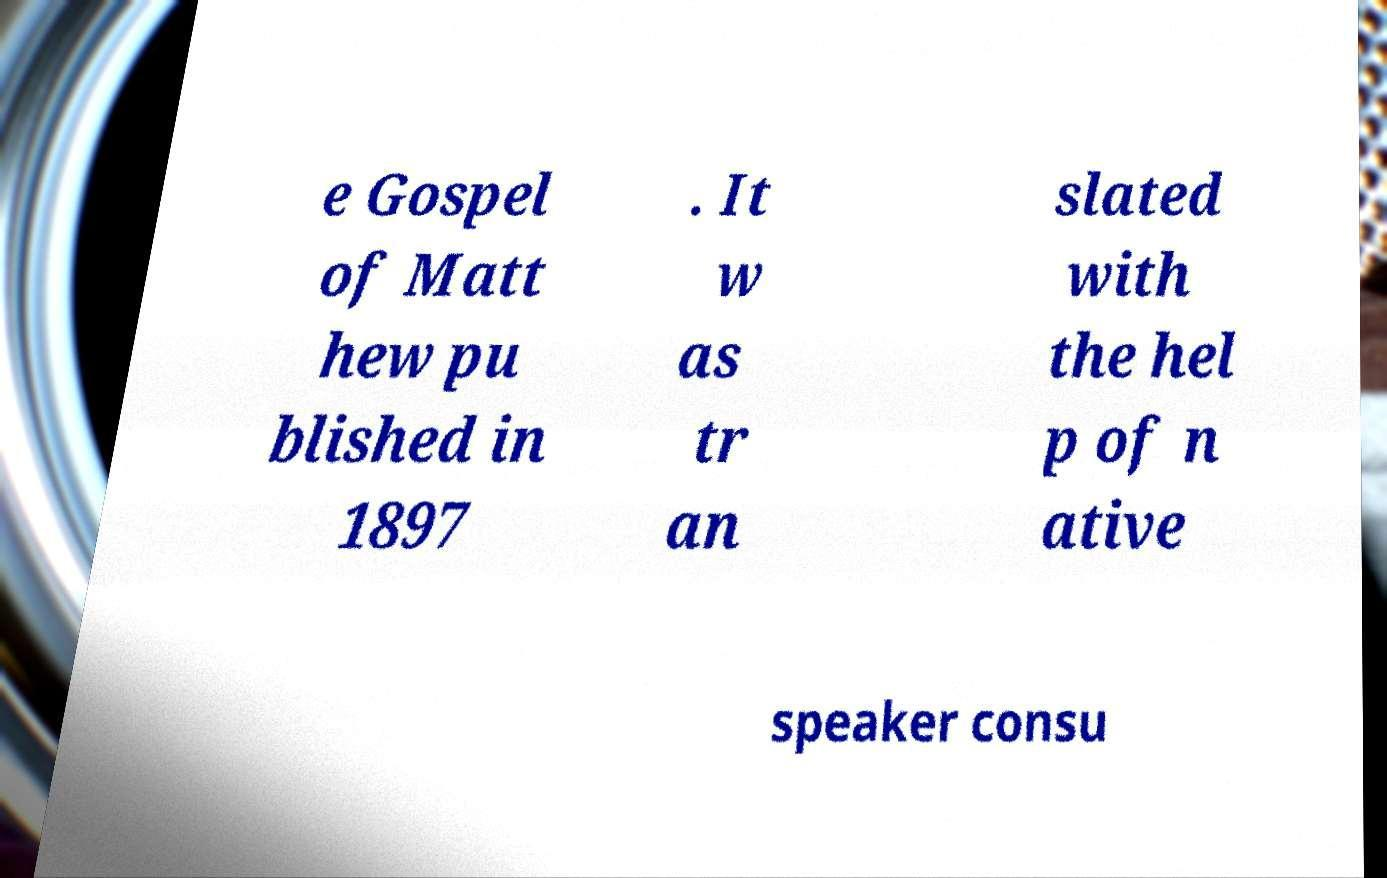Can you read and provide the text displayed in the image?This photo seems to have some interesting text. Can you extract and type it out for me? e Gospel of Matt hew pu blished in 1897 . It w as tr an slated with the hel p of n ative speaker consu 